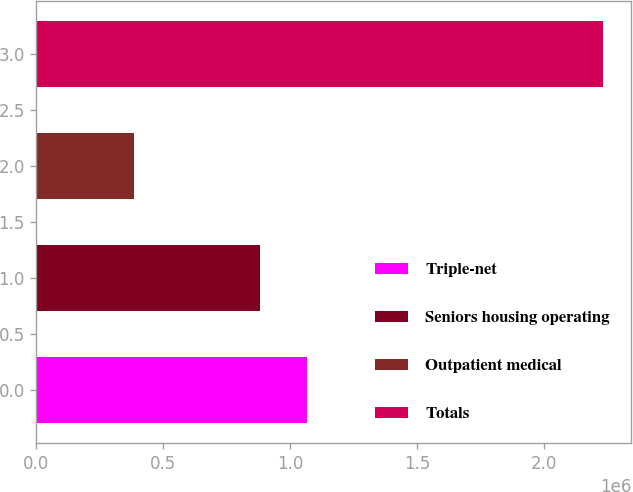<chart> <loc_0><loc_0><loc_500><loc_500><bar_chart><fcel>Triple-net<fcel>Seniors housing operating<fcel>Outpatient medical<fcel>Totals<nl><fcel>1.06474e+06<fcel>880026<fcel>384068<fcel>2.23118e+06<nl></chart> 